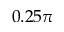<formula> <loc_0><loc_0><loc_500><loc_500>0 . 2 5 \pi</formula> 